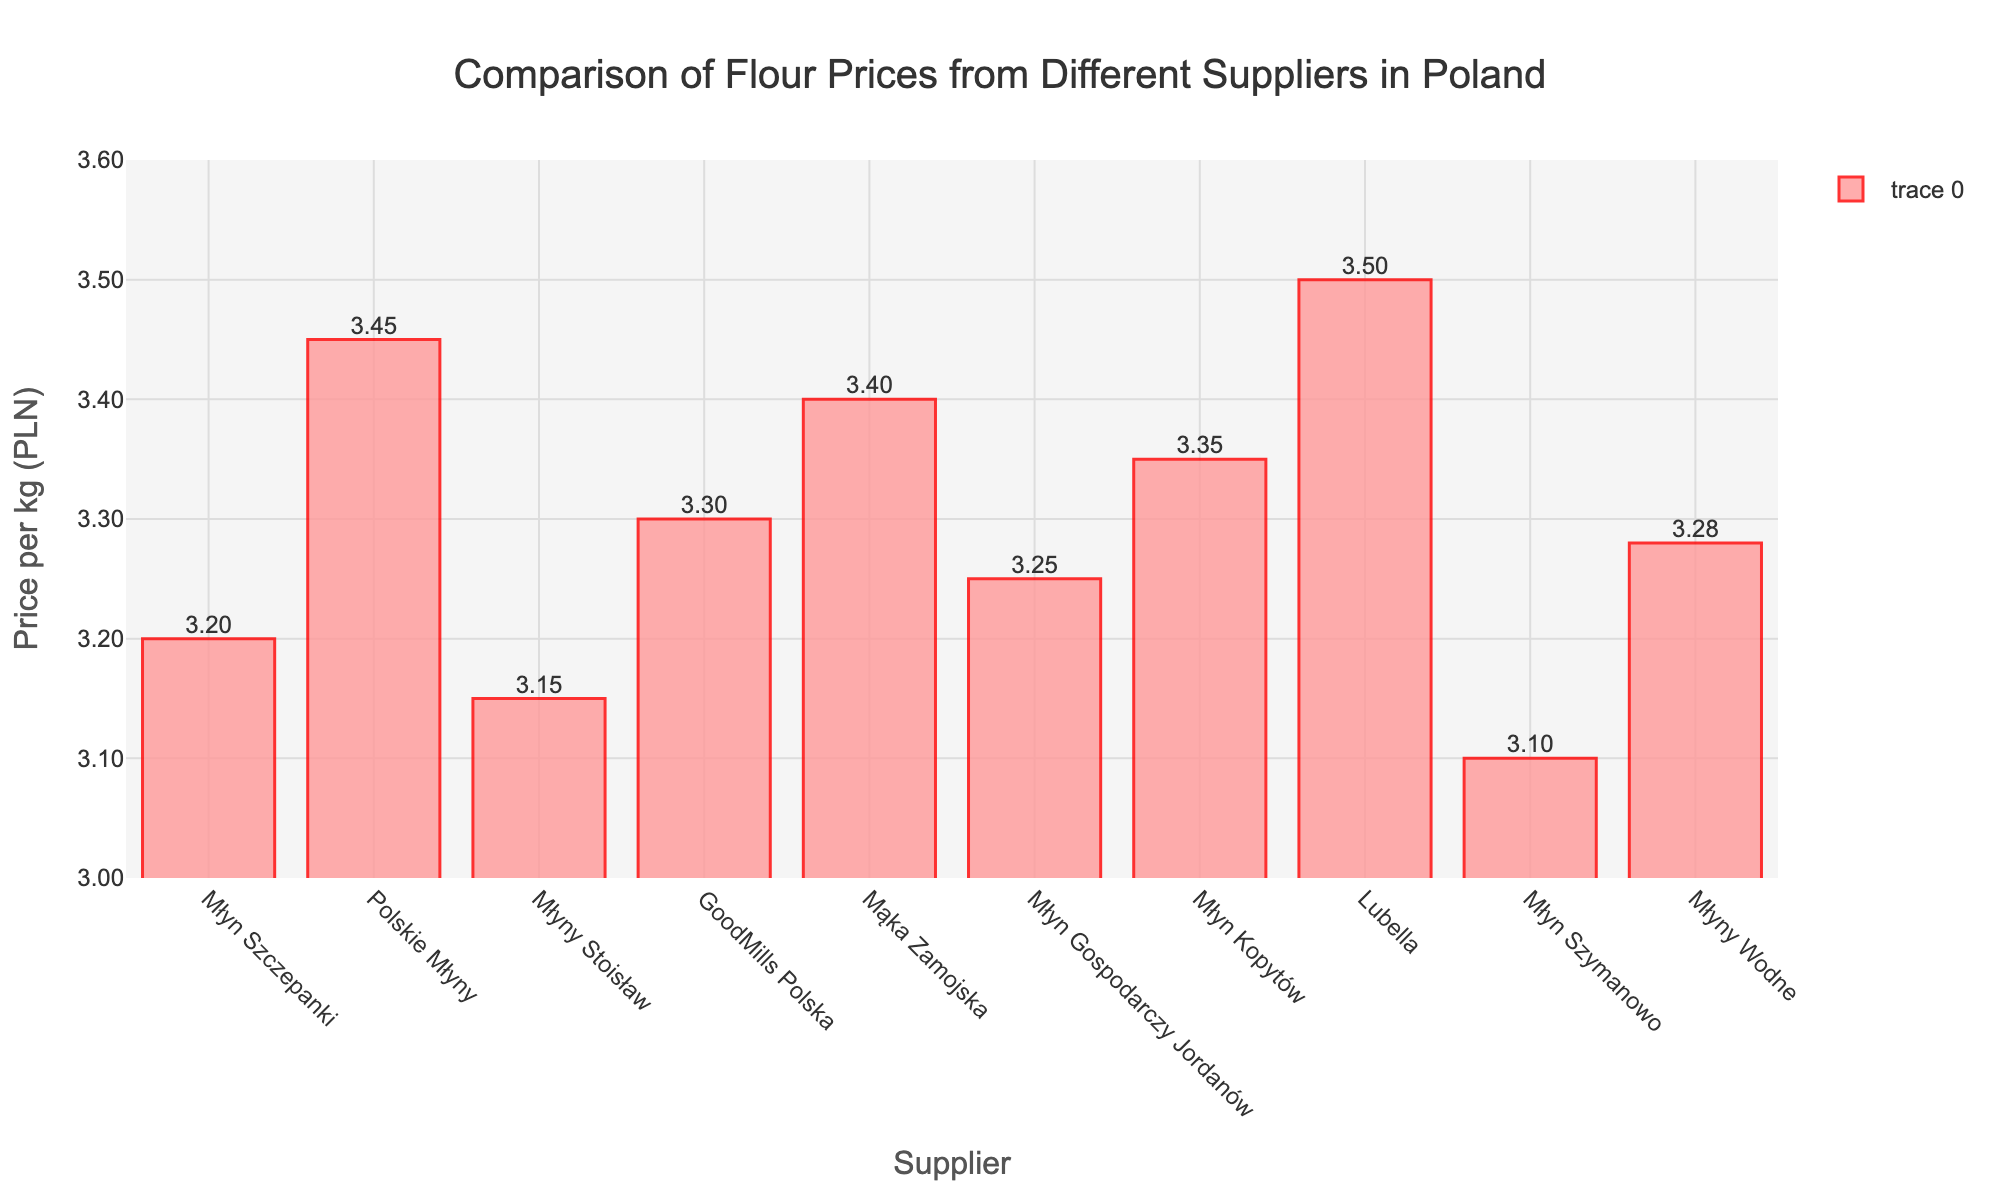What's the cheapest flour supplier? To find the cheapest flour supplier, look at the bar with the lowest height in the chart. The bar for Młyn Szymanowo is the shortest.
Answer: Młyn Szymanowo Which supplier has the highest flour price? To find the supplier with the highest price, identify the tallest bar in the chart. The tallest bar is for Lubella.
Answer: Lubella How much more expensive is Lubella compared to Młyn Szymanowo? Lubella's price is 3.50 PLN, and Młyn Szymanowo's price is 3.10 PLN. The difference is 3.50 - 3.10 = 0.40 PLN.
Answer: 0.40 PLN Are there any suppliers with the same flour price? Check if any bars are at the same height. There are no bars at identical heights, so no suppliers have the same price.
Answer: No What's the price range of the flour? The lowest price is 3.10 PLN (Młyn Szymanowo) and the highest is 3.50 PLN (Lubella). The price range is 3.50 - 3.10 = 0.40 PLN.
Answer: 0.40 PLN How many suppliers have a price below 3.30 PLN? Look at the bars that are below the 3.30 PLN level. The suppliers are Młyn Szczepanki (3.20 PLN), Młyny Stoisław (3.15 PLN), Młyn Szymanowo (3.10 PLN), so there are 3 suppliers.
Answer: 3 What's the total price if you buy 1 kg of flour from each supplier? Sum the prices of flour from all suppliers: 3.20 + 3.45 + 3.15 + 3.30 + 3.40 + 3.25 + 3.35 + 3.50 + 3.10 + 3.28 = 33.98 PLN.
Answer: 33.98 PLN Which supplier has a slightly lower price than Mąka Zamojska? Mąka Zamojska has a price of 3.40 PLN. The supplier with a slightly lower price is Młyn Kopytów with 3.35 PLN.
Answer: Młyn Kopytów What’s the average price of flour per kg from these suppliers? Add all prices and divide by the number of suppliers: (3.20 + 3.45 + 3.15 + 3.30 + 3.40 + 3.25 + 3.35 + 3.50 + 3.10 + 3.28) / 10 = 3.398 PLN.
Answer: 3.40 PLN How many suppliers charge between 3.15 PLN and 3.35 PLN for their flour? Look at the bars between 3.15 PLN and 3.35 PLN. Suppliers are Młyn Szczepanki (3.20 PLN), GoodMills Polska (3.30 PLN), Młyn Gospodarczy Jordanów (3.25 PLN), Młyn Kopytów (3.35 PLN), Młyny Wodne (3.28 PLN). There are 5 suppliers.
Answer: 5 